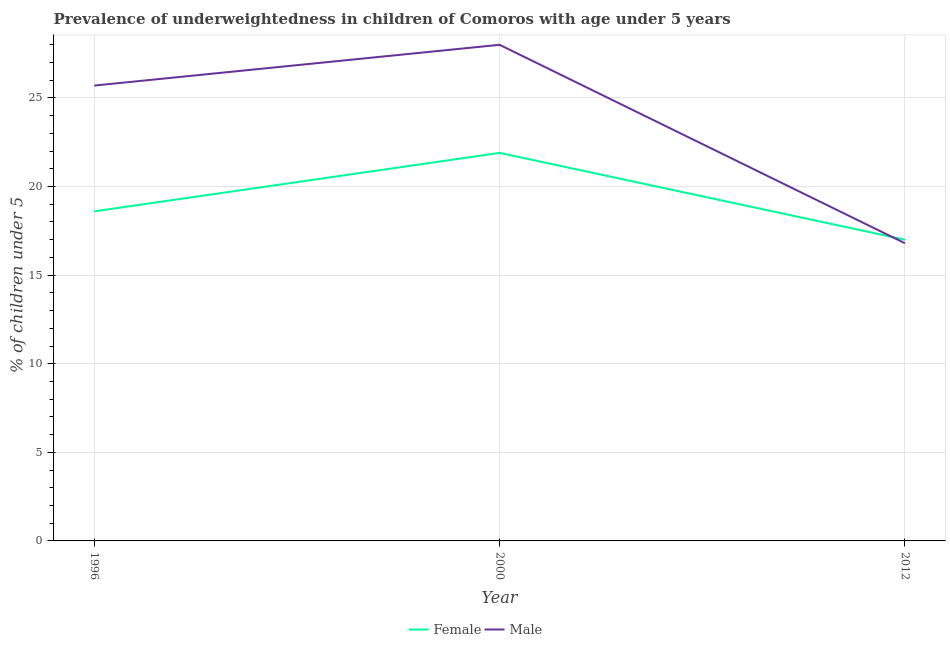How many different coloured lines are there?
Provide a short and direct response. 2. Does the line corresponding to percentage of underweighted female children intersect with the line corresponding to percentage of underweighted male children?
Offer a very short reply. Yes. What is the percentage of underweighted female children in 2000?
Make the answer very short. 21.9. Across all years, what is the maximum percentage of underweighted female children?
Provide a succinct answer. 21.9. Across all years, what is the minimum percentage of underweighted male children?
Keep it short and to the point. 16.8. What is the total percentage of underweighted female children in the graph?
Provide a short and direct response. 57.5. What is the difference between the percentage of underweighted female children in 1996 and that in 2012?
Your answer should be compact. 1.6. What is the difference between the percentage of underweighted female children in 2012 and the percentage of underweighted male children in 2000?
Your answer should be very brief. -11. What is the average percentage of underweighted female children per year?
Make the answer very short. 19.17. In the year 2012, what is the difference between the percentage of underweighted male children and percentage of underweighted female children?
Provide a short and direct response. -0.2. In how many years, is the percentage of underweighted female children greater than 22 %?
Keep it short and to the point. 0. What is the ratio of the percentage of underweighted female children in 2000 to that in 2012?
Offer a very short reply. 1.29. Is the difference between the percentage of underweighted female children in 1996 and 2000 greater than the difference between the percentage of underweighted male children in 1996 and 2000?
Provide a short and direct response. No. What is the difference between the highest and the second highest percentage of underweighted male children?
Ensure brevity in your answer.  2.3. What is the difference between the highest and the lowest percentage of underweighted female children?
Your response must be concise. 4.9. In how many years, is the percentage of underweighted male children greater than the average percentage of underweighted male children taken over all years?
Ensure brevity in your answer.  2. Is the sum of the percentage of underweighted female children in 1996 and 2012 greater than the maximum percentage of underweighted male children across all years?
Your answer should be very brief. Yes. Is the percentage of underweighted male children strictly less than the percentage of underweighted female children over the years?
Give a very brief answer. No. What is the difference between two consecutive major ticks on the Y-axis?
Your answer should be very brief. 5. Are the values on the major ticks of Y-axis written in scientific E-notation?
Offer a terse response. No. Does the graph contain any zero values?
Your response must be concise. No. Does the graph contain grids?
Your answer should be compact. Yes. Where does the legend appear in the graph?
Offer a very short reply. Bottom center. How many legend labels are there?
Your answer should be compact. 2. How are the legend labels stacked?
Offer a terse response. Horizontal. What is the title of the graph?
Offer a very short reply. Prevalence of underweightedness in children of Comoros with age under 5 years. What is the label or title of the Y-axis?
Make the answer very short.  % of children under 5. What is the  % of children under 5 of Female in 1996?
Offer a terse response. 18.6. What is the  % of children under 5 in Male in 1996?
Provide a succinct answer. 25.7. What is the  % of children under 5 of Female in 2000?
Make the answer very short. 21.9. What is the  % of children under 5 of Female in 2012?
Provide a succinct answer. 17. What is the  % of children under 5 in Male in 2012?
Offer a very short reply. 16.8. Across all years, what is the maximum  % of children under 5 in Female?
Your answer should be very brief. 21.9. Across all years, what is the maximum  % of children under 5 in Male?
Offer a terse response. 28. Across all years, what is the minimum  % of children under 5 of Male?
Provide a succinct answer. 16.8. What is the total  % of children under 5 of Female in the graph?
Your answer should be compact. 57.5. What is the total  % of children under 5 of Male in the graph?
Your response must be concise. 70.5. What is the difference between the  % of children under 5 in Female in 1996 and that in 2000?
Keep it short and to the point. -3.3. What is the difference between the  % of children under 5 in Male in 1996 and that in 2000?
Provide a succinct answer. -2.3. What is the average  % of children under 5 in Female per year?
Offer a very short reply. 19.17. What is the average  % of children under 5 of Male per year?
Your response must be concise. 23.5. In the year 1996, what is the difference between the  % of children under 5 of Female and  % of children under 5 of Male?
Your answer should be very brief. -7.1. In the year 2000, what is the difference between the  % of children under 5 of Female and  % of children under 5 of Male?
Offer a terse response. -6.1. In the year 2012, what is the difference between the  % of children under 5 in Female and  % of children under 5 in Male?
Give a very brief answer. 0.2. What is the ratio of the  % of children under 5 of Female in 1996 to that in 2000?
Make the answer very short. 0.85. What is the ratio of the  % of children under 5 in Male in 1996 to that in 2000?
Give a very brief answer. 0.92. What is the ratio of the  % of children under 5 of Female in 1996 to that in 2012?
Your answer should be compact. 1.09. What is the ratio of the  % of children under 5 in Male in 1996 to that in 2012?
Provide a short and direct response. 1.53. What is the ratio of the  % of children under 5 in Female in 2000 to that in 2012?
Offer a terse response. 1.29. What is the ratio of the  % of children under 5 of Male in 2000 to that in 2012?
Offer a very short reply. 1.67. 